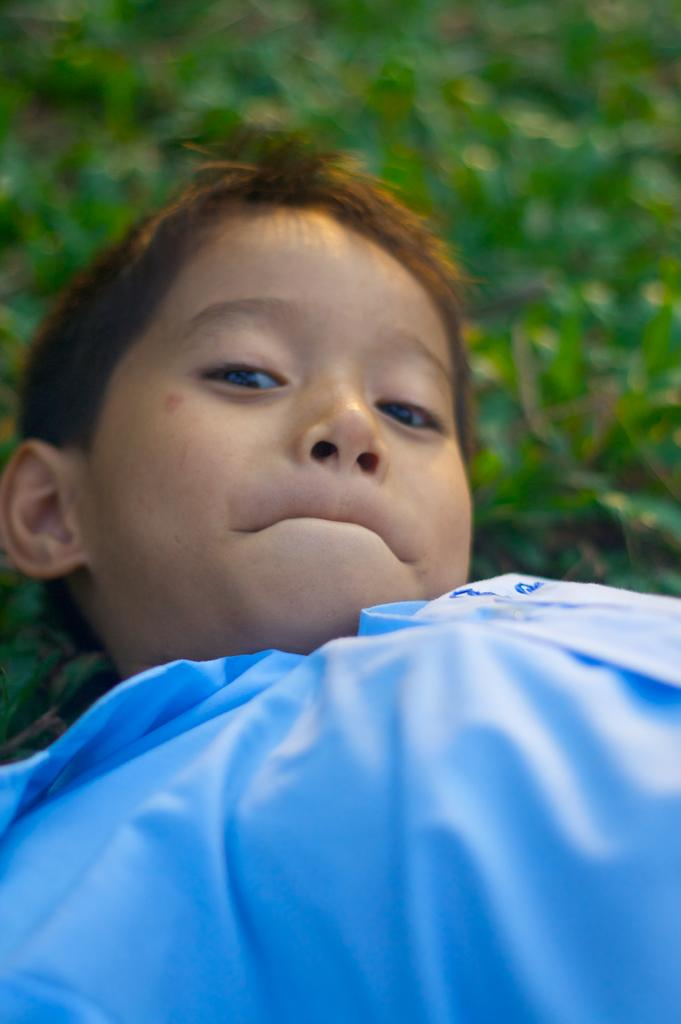What is the main subject of the picture? The main subject of the picture is a boy. What is the boy wearing in the image? The boy is wearing a shirt in the image. Can you describe the background of the image? The background of the image is blurry. What type of dinner is being served in the alley in the image? There is no alley or dinner present in the image; it features a boy wearing a shirt with a blurry background. 